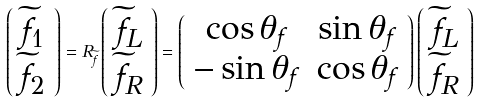<formula> <loc_0><loc_0><loc_500><loc_500>\left ( \begin{array} { c } { \widetilde { f } } _ { 1 } \\ { \widetilde { f } } _ { 2 } \end{array} \right ) = R _ { { \widetilde { f } } } \left ( \begin{array} { c } { \widetilde { f } } _ { L } \\ { \widetilde { f } } _ { R } \end{array} \right ) = \left ( \begin{array} { c c } \cos { { \theta } _ { f } } & \sin { { \theta } _ { f } } \\ - \sin { \theta } _ { f } & \cos { \theta } _ { f } \end{array} \right ) \left ( \begin{array} { c } { \widetilde { f } } _ { L } \\ { \widetilde { f } } _ { R } \end{array} \right )</formula> 